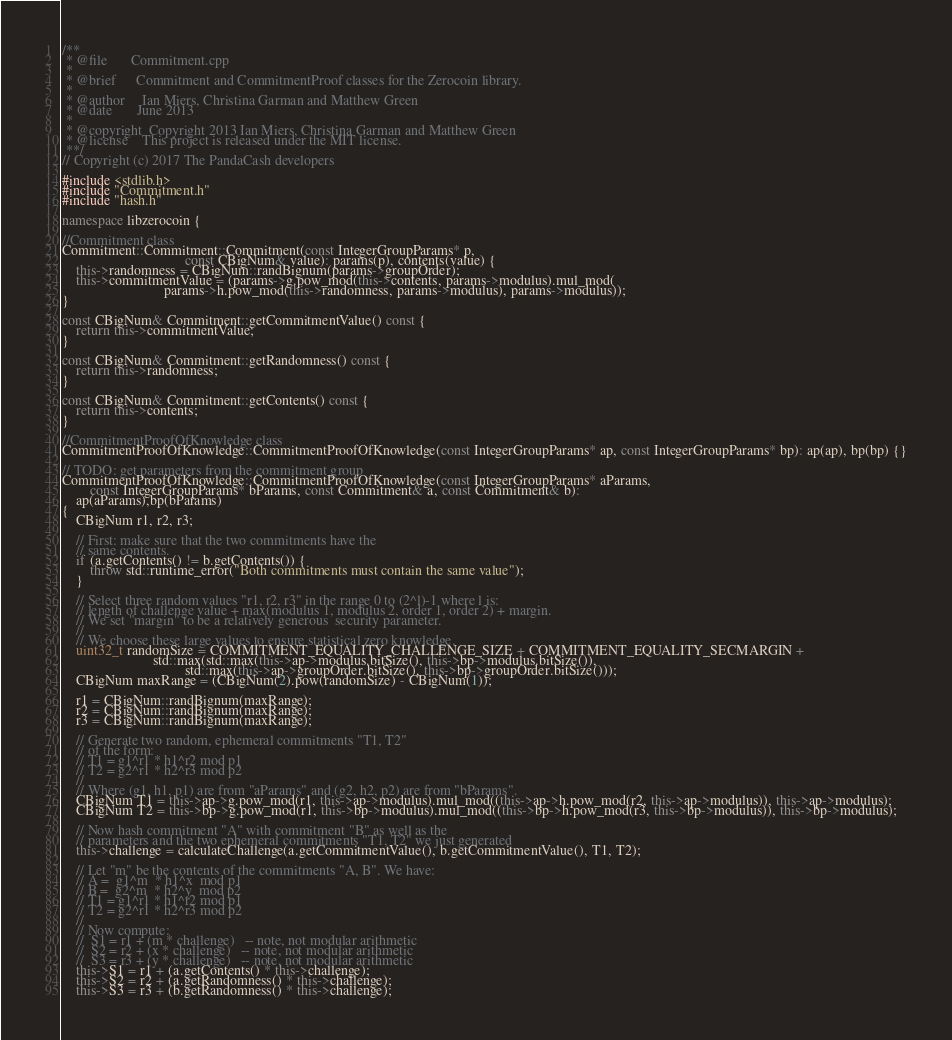<code> <loc_0><loc_0><loc_500><loc_500><_C++_>/**
 * @file       Commitment.cpp
 *
 * @brief      Commitment and CommitmentProof classes for the Zerocoin library.
 *
 * @author     Ian Miers, Christina Garman and Matthew Green
 * @date       June 2013
 *
 * @copyright  Copyright 2013 Ian Miers, Christina Garman and Matthew Green
 * @license    This project is released under the MIT license.
 **/
// Copyright (c) 2017 The PandaCash developers

#include <stdlib.h>
#include "Commitment.h"
#include "hash.h"

namespace libzerocoin {

//Commitment class
Commitment::Commitment::Commitment(const IntegerGroupParams* p,
                                   const CBigNum& value): params(p), contents(value) {
	this->randomness = CBigNum::randBignum(params->groupOrder);
	this->commitmentValue = (params->g.pow_mod(this->contents, params->modulus).mul_mod(
	                         params->h.pow_mod(this->randomness, params->modulus), params->modulus));
}

const CBigNum& Commitment::getCommitmentValue() const {
	return this->commitmentValue;
}

const CBigNum& Commitment::getRandomness() const {
	return this->randomness;
}

const CBigNum& Commitment::getContents() const {
	return this->contents;
}

//CommitmentProofOfKnowledge class
CommitmentProofOfKnowledge::CommitmentProofOfKnowledge(const IntegerGroupParams* ap, const IntegerGroupParams* bp): ap(ap), bp(bp) {}

// TODO: get parameters from the commitment group
CommitmentProofOfKnowledge::CommitmentProofOfKnowledge(const IntegerGroupParams* aParams,
        const IntegerGroupParams* bParams, const Commitment& a, const Commitment& b):
	ap(aParams),bp(bParams)
{
	CBigNum r1, r2, r3;

	// First: make sure that the two commitments have the
	// same contents.
	if (a.getContents() != b.getContents()) {
		throw std::runtime_error("Both commitments must contain the same value");
	}

	// Select three random values "r1, r2, r3" in the range 0 to (2^l)-1 where l is:
	// length of challenge value + max(modulus 1, modulus 2, order 1, order 2) + margin.
	// We set "margin" to be a relatively generous  security parameter.
	//
	// We choose these large values to ensure statistical zero knowledge.
	uint32_t randomSize = COMMITMENT_EQUALITY_CHALLENGE_SIZE + COMMITMENT_EQUALITY_SECMARGIN +
	                      std::max(std::max(this->ap->modulus.bitSize(), this->bp->modulus.bitSize()),
	                               std::max(this->ap->groupOrder.bitSize(), this->bp->groupOrder.bitSize()));
	CBigNum maxRange = (CBigNum(2).pow(randomSize) - CBigNum(1));

	r1 = CBigNum::randBignum(maxRange);
	r2 = CBigNum::randBignum(maxRange);
	r3 = CBigNum::randBignum(maxRange);

	// Generate two random, ephemeral commitments "T1, T2"
	// of the form:
	// T1 = g1^r1 * h1^r2 mod p1
	// T2 = g2^r1 * h2^r3 mod p2
	//
	// Where (g1, h1, p1) are from "aParams" and (g2, h2, p2) are from "bParams".
	CBigNum T1 = this->ap->g.pow_mod(r1, this->ap->modulus).mul_mod((this->ap->h.pow_mod(r2, this->ap->modulus)), this->ap->modulus);
	CBigNum T2 = this->bp->g.pow_mod(r1, this->bp->modulus).mul_mod((this->bp->h.pow_mod(r3, this->bp->modulus)), this->bp->modulus);

	// Now hash commitment "A" with commitment "B" as well as the
	// parameters and the two ephemeral commitments "T1, T2" we just generated
	this->challenge = calculateChallenge(a.getCommitmentValue(), b.getCommitmentValue(), T1, T2);

	// Let "m" be the contents of the commitments "A, B". We have:
	// A =  g1^m  * h1^x  mod p1
	// B =  g2^m  * h2^y  mod p2
	// T1 = g1^r1 * h1^r2 mod p1
	// T2 = g2^r1 * h2^r3 mod p2
	//
	// Now compute:
	//  S1 = r1 + (m * challenge)   -- note, not modular arithmetic
	//  S2 = r2 + (x * challenge)   -- note, not modular arithmetic
	//  S3 = r3 + (y * challenge)   -- note, not modular arithmetic
	this->S1 = r1 + (a.getContents() * this->challenge);
	this->S2 = r2 + (a.getRandomness() * this->challenge);
	this->S3 = r3 + (b.getRandomness() * this->challenge);
</code> 